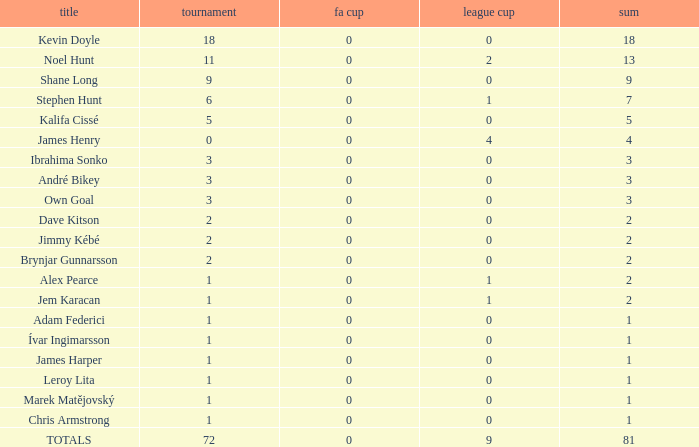What is the total championships of James Henry that has a league cup more than 1? 0.0. 